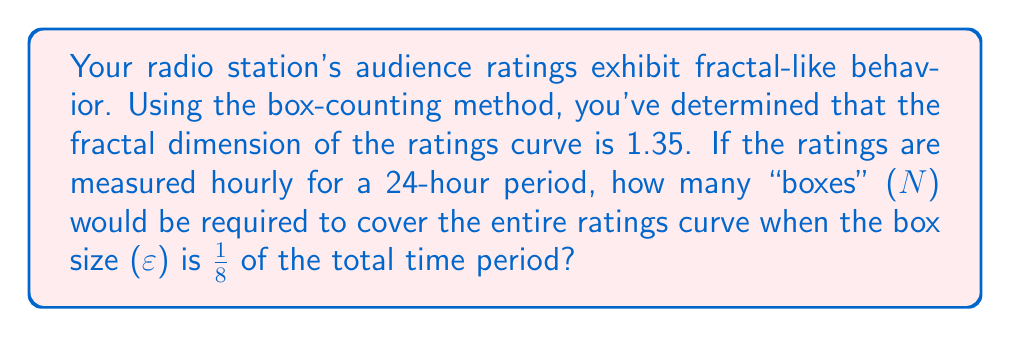Solve this math problem. To solve this problem, we'll use the fundamental relationship between fractal dimension, number of boxes, and box size in the box-counting method:

$$D = \frac{\log N}{\log(1/\epsilon)}$$

Where:
$D$ is the fractal dimension
$N$ is the number of boxes
$\epsilon$ is the box size relative to the whole

Given:
- Fractal dimension $D = 1.35$
- Box size $\epsilon = 1/8$ of the total time period

Step 1: Substitute the known values into the equation:

$$1.35 = \frac{\log N}{\log(1/(1/8))}$$

Step 2: Simplify the denominator:

$$1.35 = \frac{\log N}{\log 8}$$

Step 3: Multiply both sides by $\log 8$:

$$1.35 \log 8 = \log N$$

Step 4: Calculate $\log 8$:

$$1.35 \times 3 = \log N$$
$$4.05 = \log N$$

Step 5: Solve for $N$ by applying the exponential function to both sides:

$$N = 10^{4.05}$$

Step 6: Calculate the final value:

$$N \approx 11,220.18$$

Step 7: Round up to the nearest whole number, as we can't have a fractional box:

$$N = 11,221$$
Answer: 11,221 boxes 